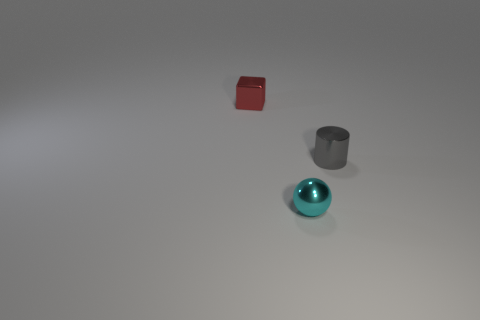There is a thing right of the small cyan shiny ball; does it have the same color as the tiny metallic thing that is in front of the small cylinder?
Give a very brief answer. No. What number of matte objects are either small red objects or large yellow cylinders?
Offer a terse response. 0. What number of small red shiny objects are to the right of the thing that is behind the tiny metallic thing on the right side of the cyan object?
Make the answer very short. 0. There is a red cube that is the same material as the cyan thing; what is its size?
Make the answer very short. Small. There is a shiny object behind the gray cylinder; is its size the same as the tiny gray thing?
Provide a short and direct response. Yes. The tiny thing that is both behind the metallic ball and left of the small gray object is what color?
Keep it short and to the point. Red. How many things are either blocks or tiny shiny things that are to the right of the cyan metal ball?
Your answer should be compact. 2. What material is the thing that is in front of the small metallic thing on the right side of the object in front of the gray cylinder made of?
Provide a succinct answer. Metal. Are there any other things that are made of the same material as the small red cube?
Provide a succinct answer. Yes. There is a object in front of the cylinder; is it the same color as the small cylinder?
Make the answer very short. No. 